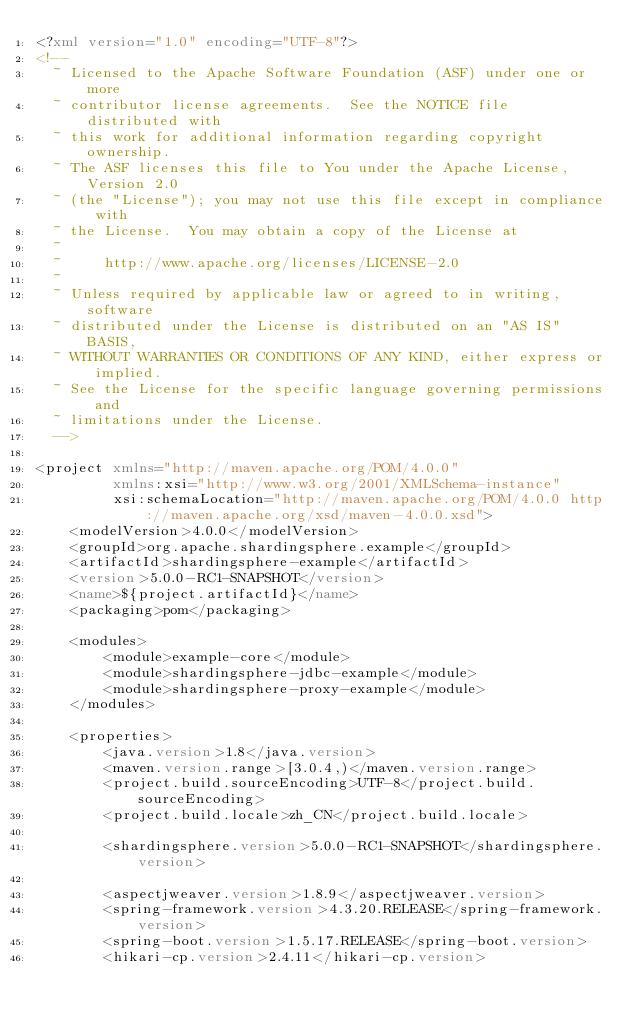<code> <loc_0><loc_0><loc_500><loc_500><_XML_><?xml version="1.0" encoding="UTF-8"?>
<!--
  ~ Licensed to the Apache Software Foundation (ASF) under one or more
  ~ contributor license agreements.  See the NOTICE file distributed with
  ~ this work for additional information regarding copyright ownership.
  ~ The ASF licenses this file to You under the Apache License, Version 2.0
  ~ (the "License"); you may not use this file except in compliance with
  ~ the License.  You may obtain a copy of the License at
  ~
  ~     http://www.apache.org/licenses/LICENSE-2.0
  ~
  ~ Unless required by applicable law or agreed to in writing, software
  ~ distributed under the License is distributed on an "AS IS" BASIS,
  ~ WITHOUT WARRANTIES OR CONDITIONS OF ANY KIND, either express or implied.
  ~ See the License for the specific language governing permissions and
  ~ limitations under the License.
  -->

<project xmlns="http://maven.apache.org/POM/4.0.0"
         xmlns:xsi="http://www.w3.org/2001/XMLSchema-instance"
         xsi:schemaLocation="http://maven.apache.org/POM/4.0.0 http://maven.apache.org/xsd/maven-4.0.0.xsd">
    <modelVersion>4.0.0</modelVersion>
    <groupId>org.apache.shardingsphere.example</groupId>
    <artifactId>shardingsphere-example</artifactId>
    <version>5.0.0-RC1-SNAPSHOT</version>
    <name>${project.artifactId}</name>
    <packaging>pom</packaging>
    
    <modules>
        <module>example-core</module>
        <module>shardingsphere-jdbc-example</module>
        <module>shardingsphere-proxy-example</module>
    </modules>
    
    <properties>
        <java.version>1.8</java.version>
        <maven.version.range>[3.0.4,)</maven.version.range>
        <project.build.sourceEncoding>UTF-8</project.build.sourceEncoding>
        <project.build.locale>zh_CN</project.build.locale>
        
        <shardingsphere.version>5.0.0-RC1-SNAPSHOT</shardingsphere.version>
        
        <aspectjweaver.version>1.8.9</aspectjweaver.version>
        <spring-framework.version>4.3.20.RELEASE</spring-framework.version>
        <spring-boot.version>1.5.17.RELEASE</spring-boot.version>
        <hikari-cp.version>2.4.11</hikari-cp.version></code> 